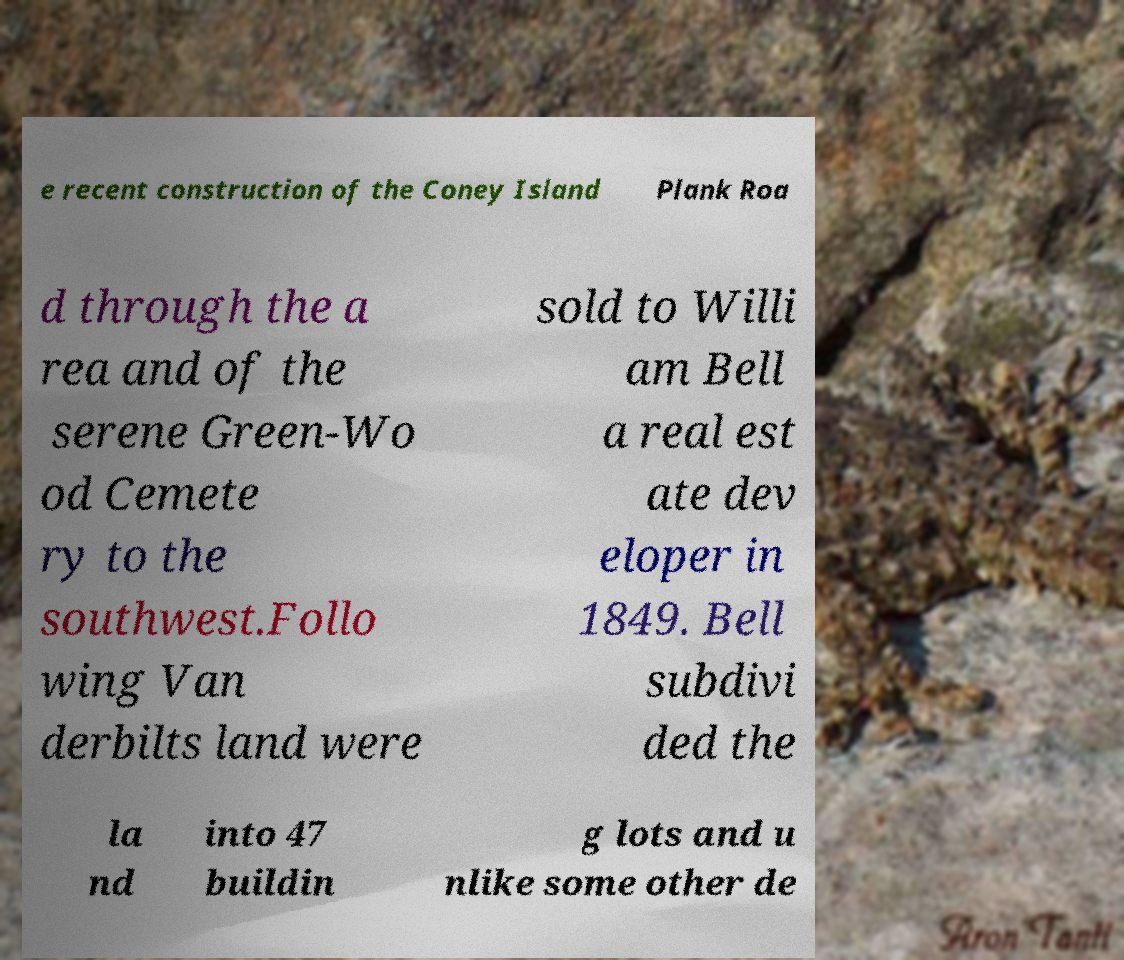Could you assist in decoding the text presented in this image and type it out clearly? e recent construction of the Coney Island Plank Roa d through the a rea and of the serene Green-Wo od Cemete ry to the southwest.Follo wing Van derbilts land were sold to Willi am Bell a real est ate dev eloper in 1849. Bell subdivi ded the la nd into 47 buildin g lots and u nlike some other de 